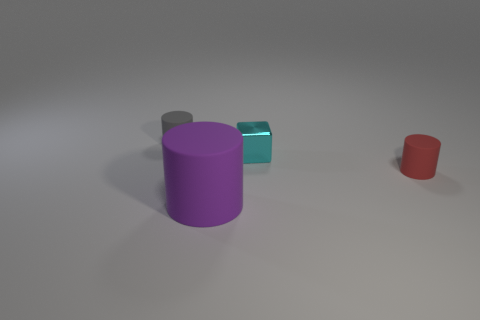Subtract all big purple rubber cylinders. How many cylinders are left? 2 Add 1 tiny cylinders. How many objects exist? 5 Subtract all red cylinders. How many cylinders are left? 2 Subtract all cubes. How many objects are left? 3 Subtract all cyan spheres. How many yellow blocks are left? 0 Subtract 0 cyan cylinders. How many objects are left? 4 Subtract 1 cylinders. How many cylinders are left? 2 Subtract all red cylinders. Subtract all gray blocks. How many cylinders are left? 2 Subtract all matte things. Subtract all red cylinders. How many objects are left? 0 Add 3 tiny matte objects. How many tiny matte objects are left? 5 